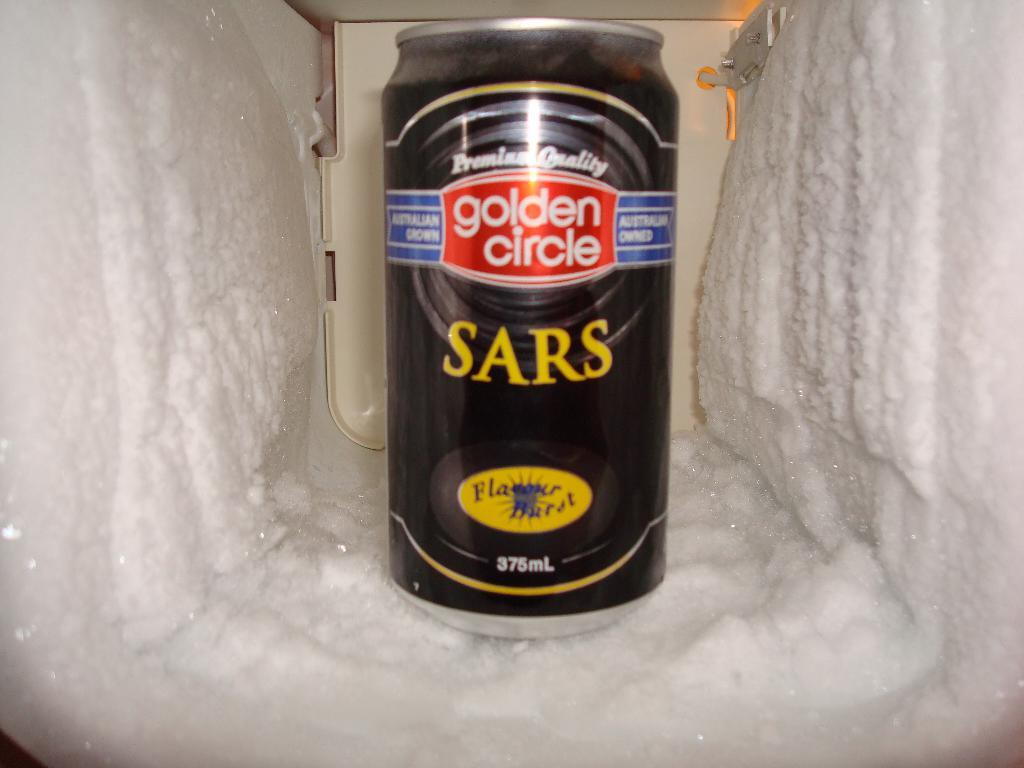What is present in the ice in the image? There is tin in the ice in the image. What historical event is depicted in the image involving the tin in the ice? There is no historical event depicted in the image; it simply shows tin in the ice. Who is the achiever responsible for placing the tin in the ice in the image? There is no specific achiever mentioned or depicted in the image; it simply shows tin in the ice. 